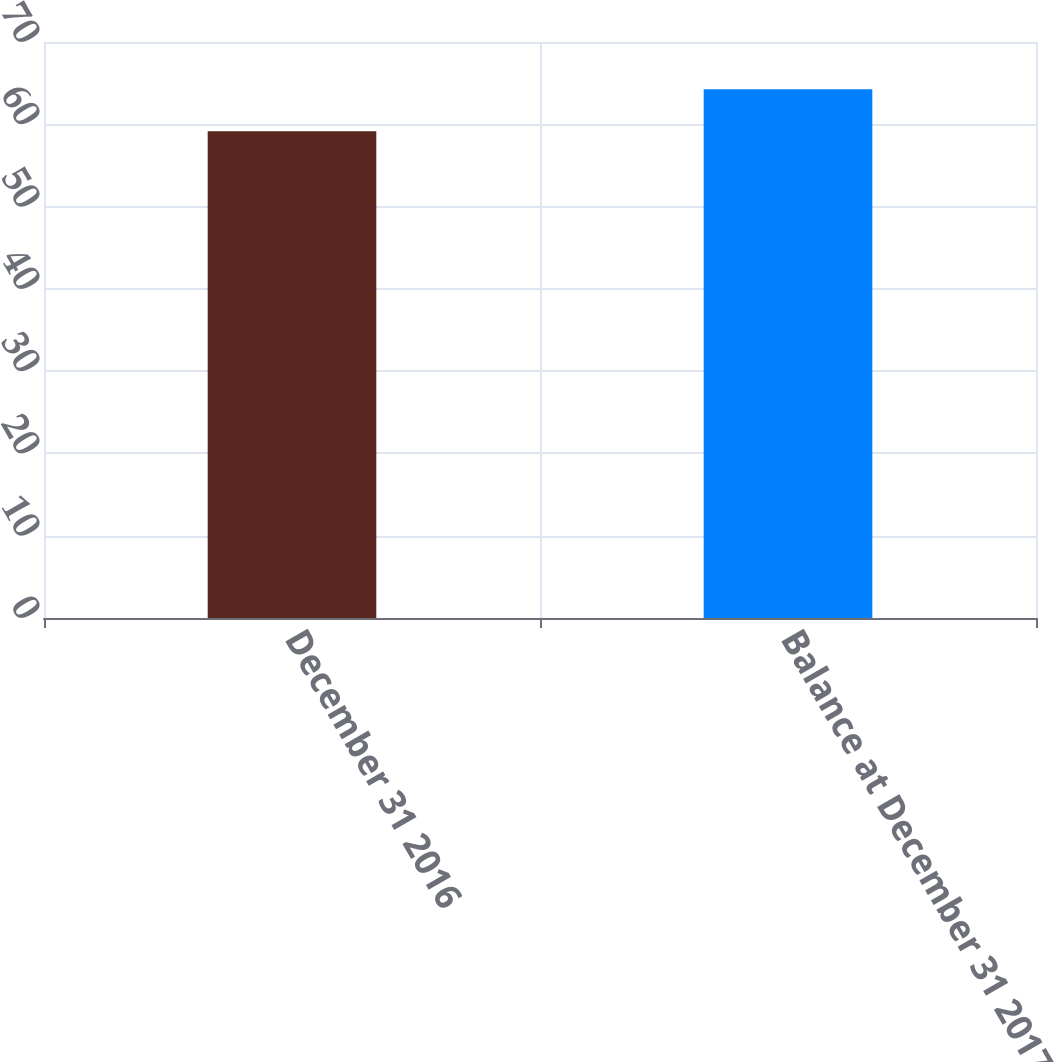Convert chart to OTSL. <chart><loc_0><loc_0><loc_500><loc_500><bar_chart><fcel>December 31 2016<fcel>Balance at December 31 2017<nl><fcel>59.14<fcel>64.25<nl></chart> 